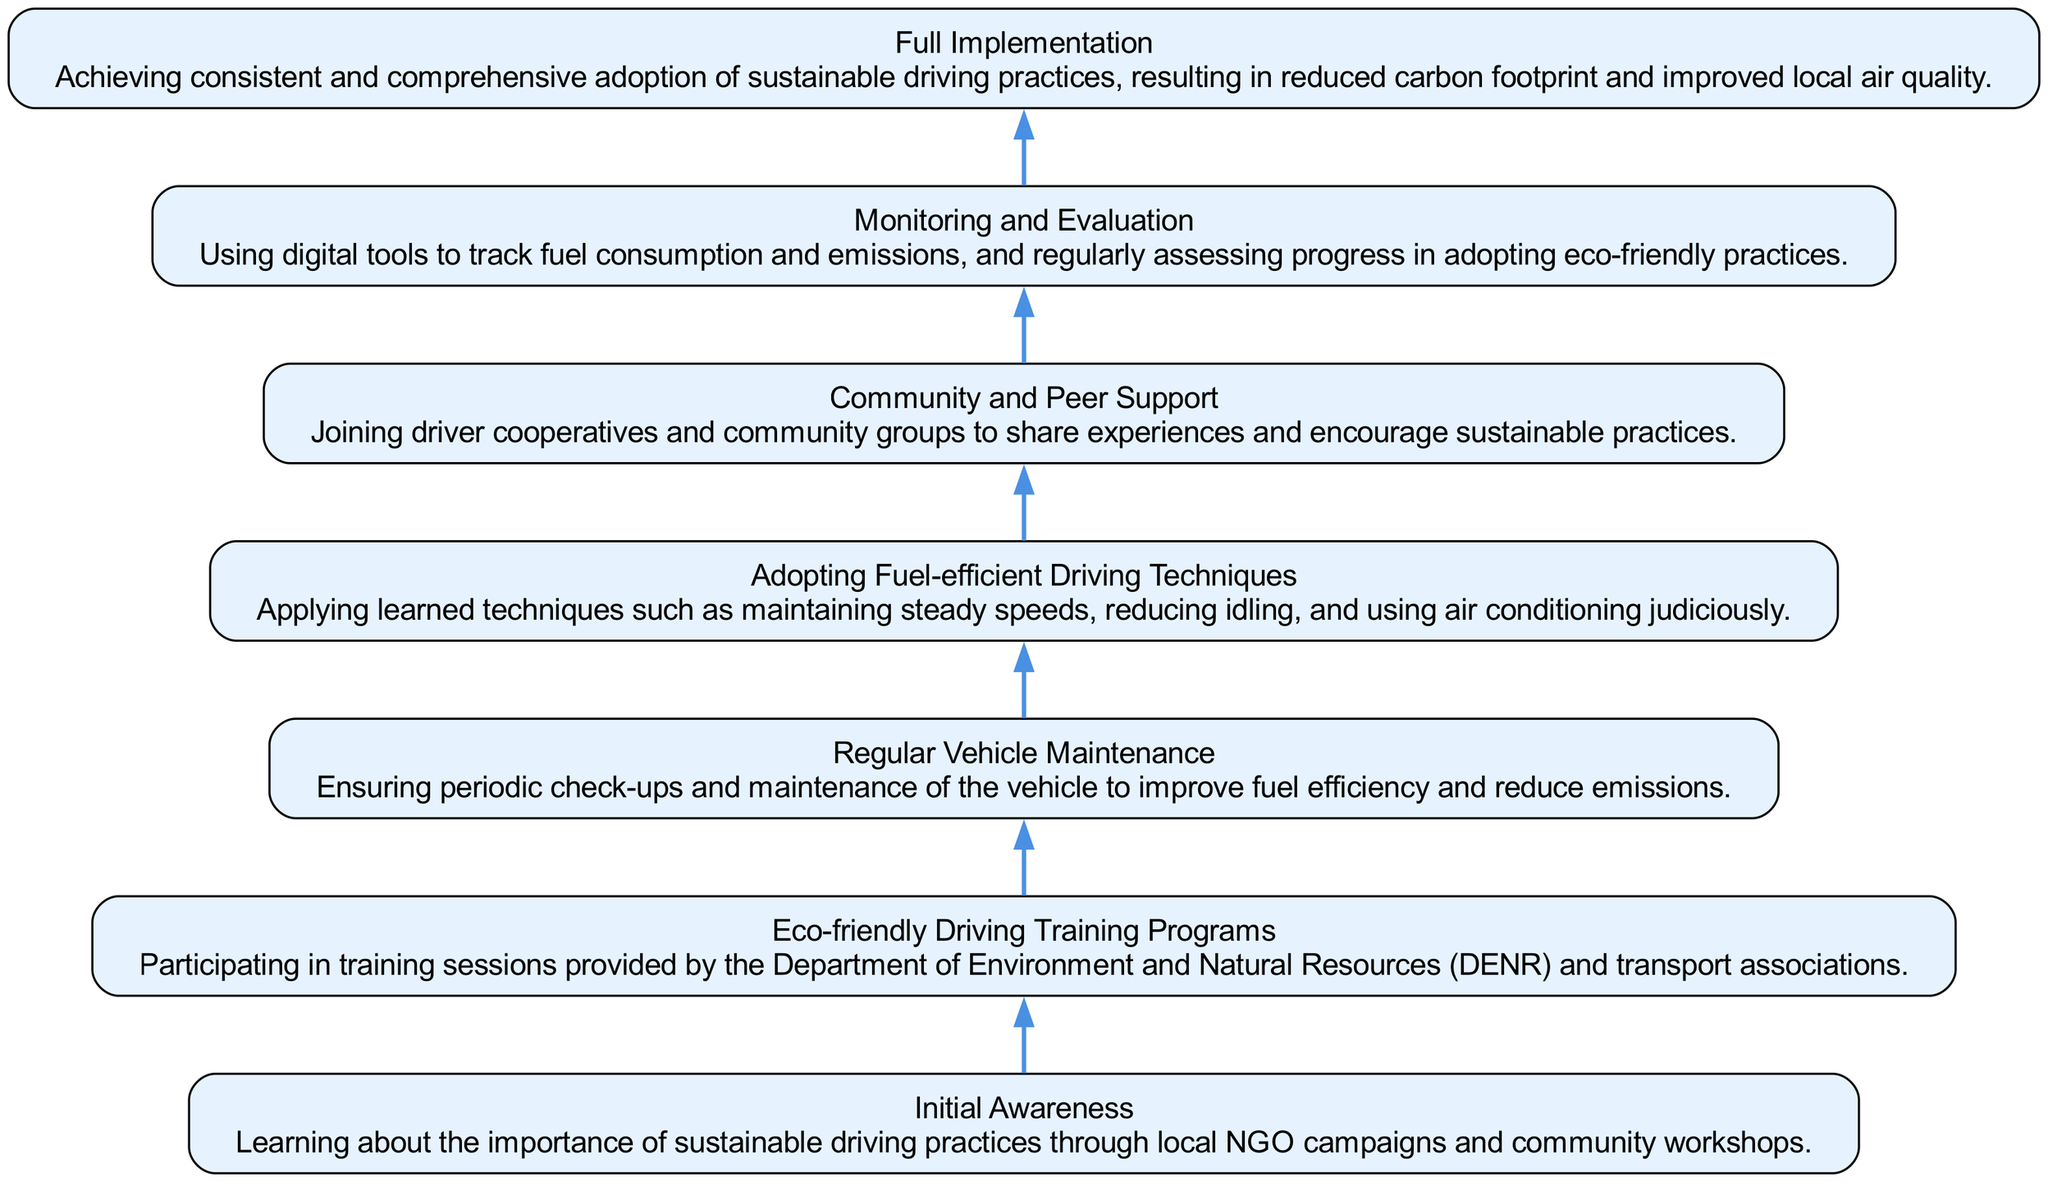What is the first stage in the adoption of sustainable driving practices? The diagram shows "Initial Awareness" as the bottommost node, indicating it is the first stage of the adoption process.
Answer: Initial Awareness How many nodes are there in the diagram? By counting all individual stages displayed in the diagram, we see there are a total of 7 nodes that represent different stages in adopting sustainable driving practices.
Answer: 7 What stage directly follows "Eco-friendly Driving Training Programs"? The diagram includes an arrow leading from "Eco-friendly Driving Training Programs" to "Vehicle Maintenance," indicating that the next step after training is to focus on maintenance.
Answer: Regular Vehicle Maintenance Which node supports community involvement in adopting eco-friendly practices? The node labeled "Community and Peer Support" directly addresses the aspect of community involvement, highlighting its role in encouraging sustainable practices among drivers.
Answer: Community and Peer Support What is the final outcome demonstrated in the diagram? The last node at the top of the diagram is labeled "Full Implementation," showing that this is the ultimate goal of the entire adoption process for sustainable driving practices.
Answer: Full Implementation How does monitoring progress relate to the stages before it? "Monitoring and Evaluation" is positioned after "Adopting Fuel-efficient Driving Techniques" and "Regular Vehicle Maintenance," indicating it builds on those practices by assessing the effectiveness and impact of the techniques learned earlier.
Answer: Monitoring and Evaluation Which two nodes illustrate the learning component of sustainable driving practices? The first two nodes, "Initial Awareness" and "Eco-friendly Driving Training Programs," focus on educating drivers about sustainable practices, detailing the learning aspect of the adoption flow.
Answer: Initial Awareness and Eco-friendly Driving Training Programs What is the relationship between "Fuel-efficient Driving Techniques" and "Monitoring and Evaluation"? The flow in the diagram shows that "Fuel-efficient Driving Techniques" must be practiced before moving to "Monitoring and Evaluation," indicating that evaluation occurs after applying the techniques.
Answer: Monitoring and Evaluation is after Fuel-efficient Driving Techniques 